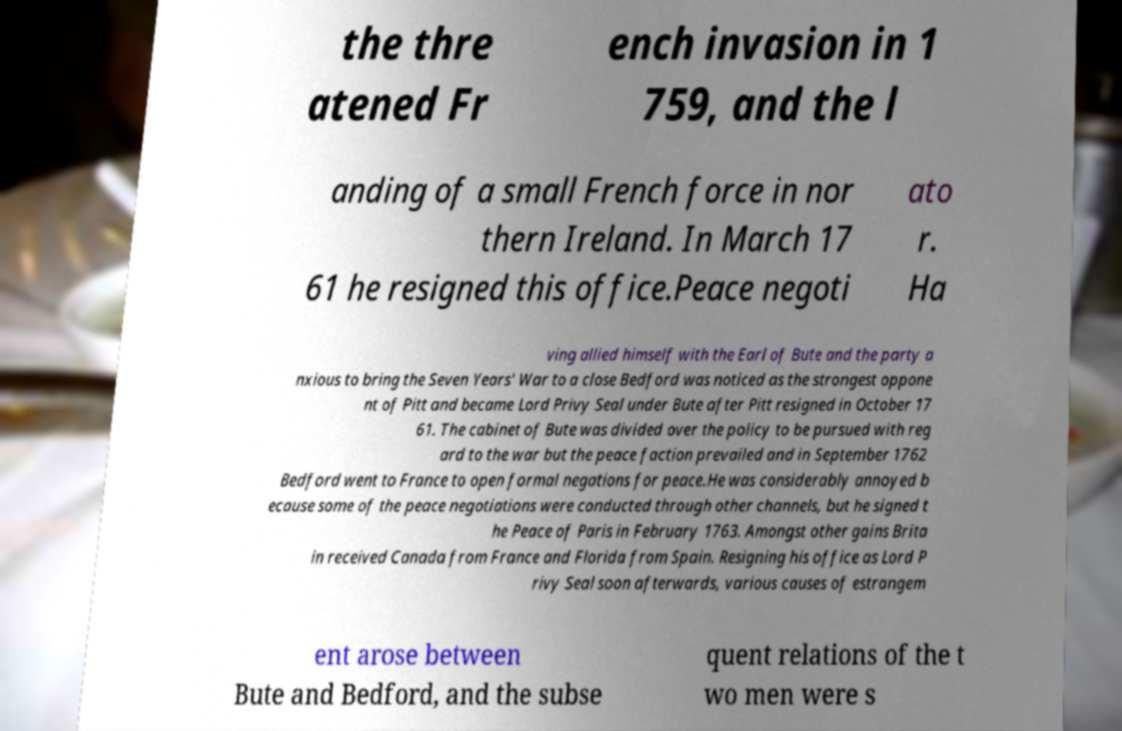There's text embedded in this image that I need extracted. Can you transcribe it verbatim? the thre atened Fr ench invasion in 1 759, and the l anding of a small French force in nor thern Ireland. In March 17 61 he resigned this office.Peace negoti ato r. Ha ving allied himself with the Earl of Bute and the party a nxious to bring the Seven Years' War to a close Bedford was noticed as the strongest oppone nt of Pitt and became Lord Privy Seal under Bute after Pitt resigned in October 17 61. The cabinet of Bute was divided over the policy to be pursued with reg ard to the war but the peace faction prevailed and in September 1762 Bedford went to France to open formal negations for peace.He was considerably annoyed b ecause some of the peace negotiations were conducted through other channels, but he signed t he Peace of Paris in February 1763. Amongst other gains Brita in received Canada from France and Florida from Spain. Resigning his office as Lord P rivy Seal soon afterwards, various causes of estrangem ent arose between Bute and Bedford, and the subse quent relations of the t wo men were s 